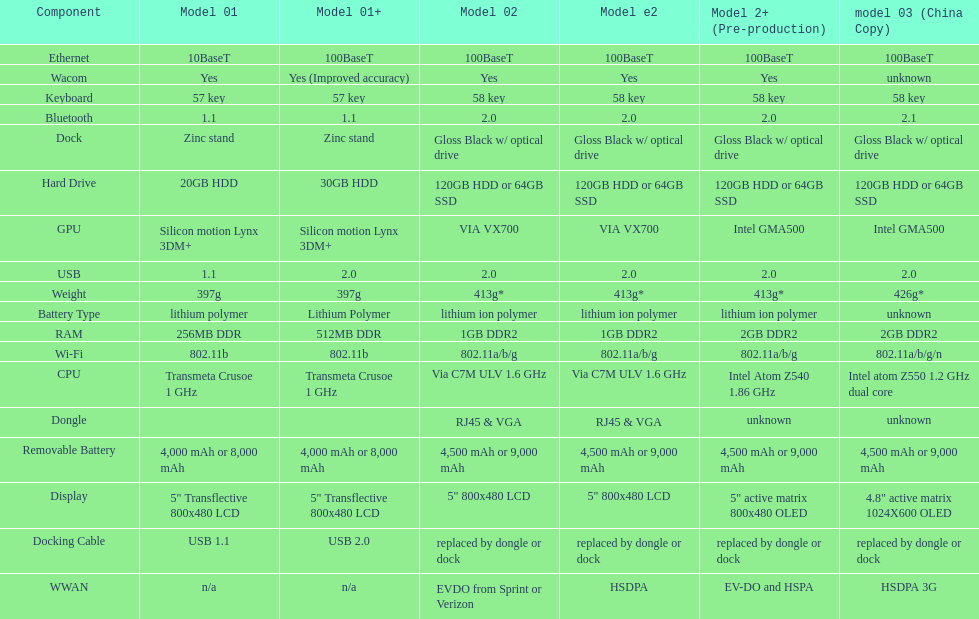The model 2 and the model 2e have what type of cpu? Via C7M ULV 1.6 GHz. 